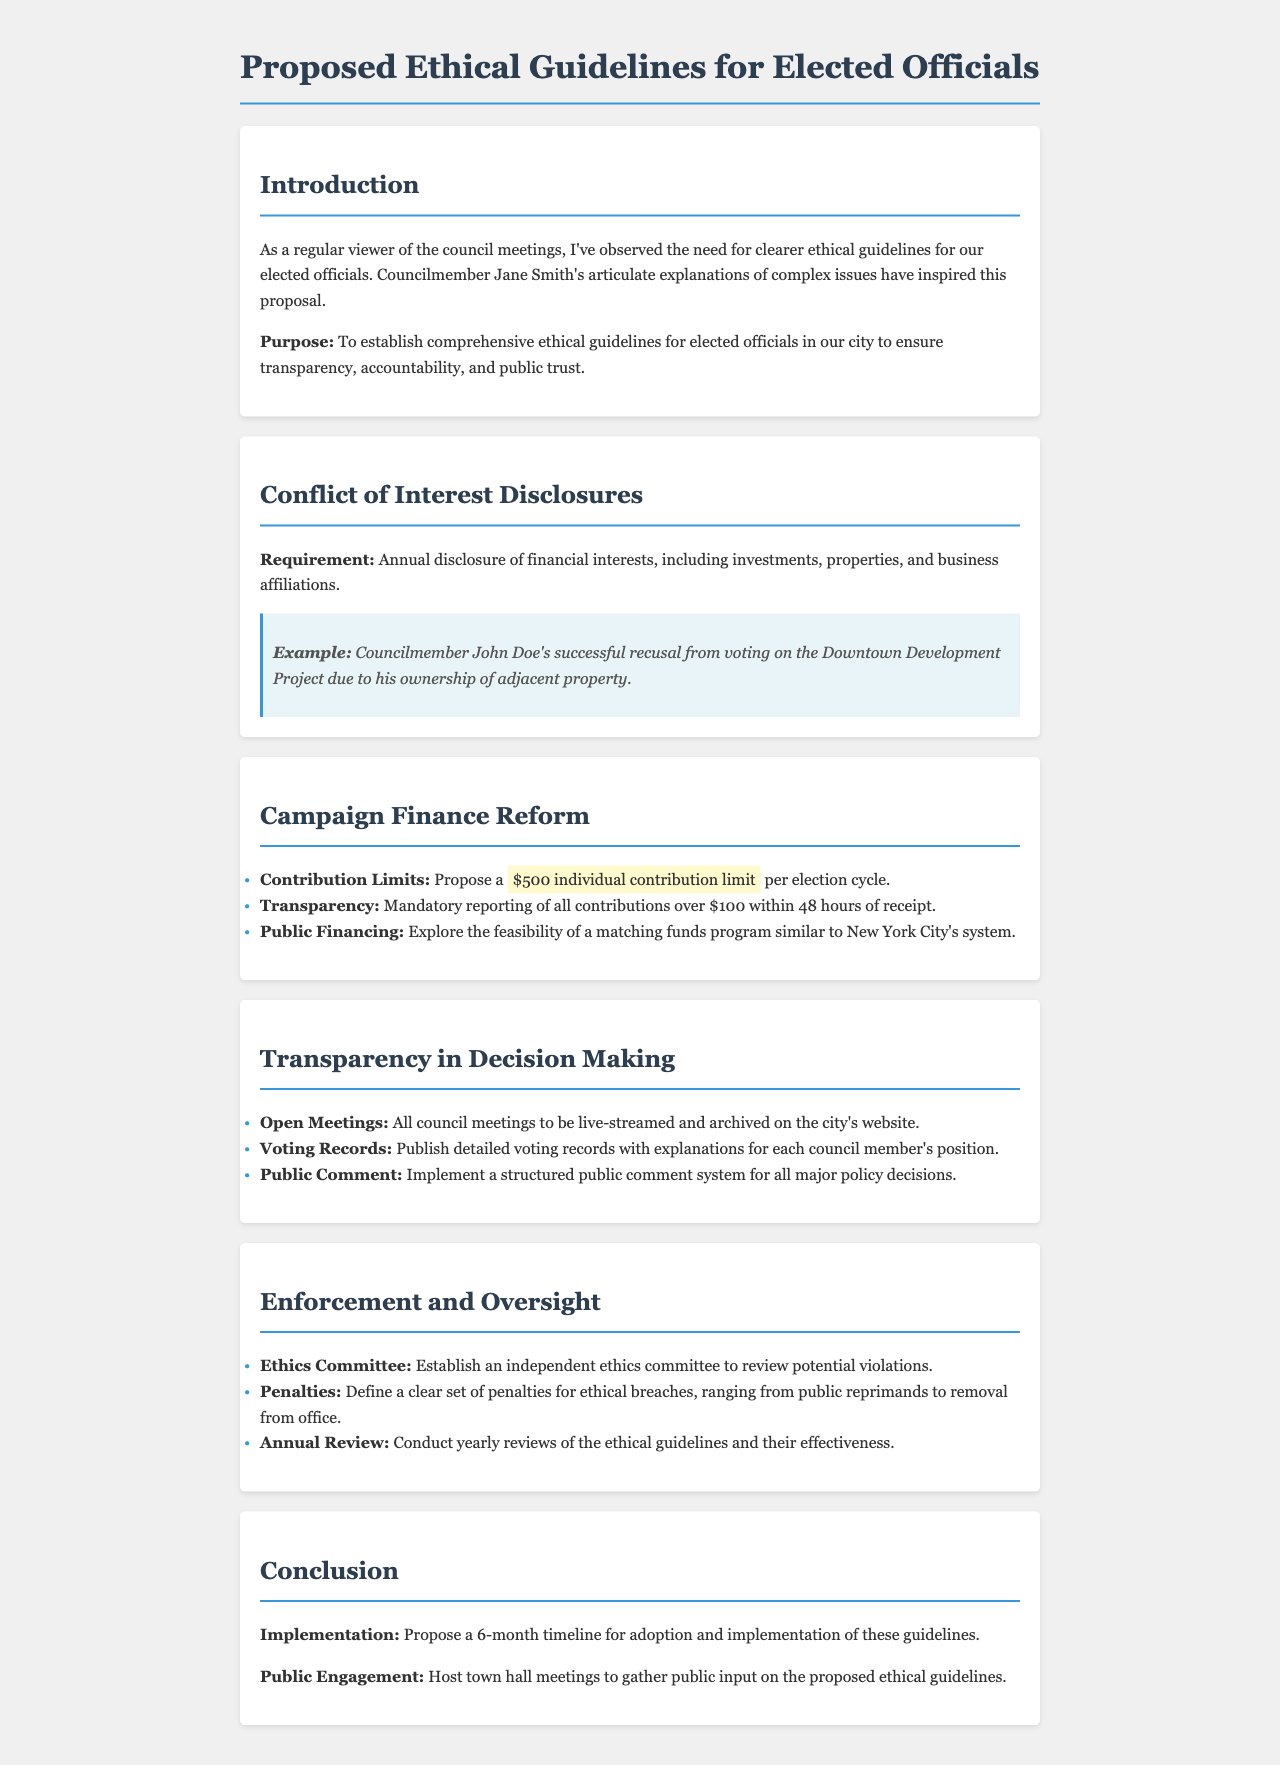what is the purpose of the proposed guidelines? The purpose is to establish comprehensive ethical guidelines for elected officials in our city to ensure transparency, accountability, and public trust.
Answer: to establish comprehensive ethical guidelines what is the annual disclosure requirement for elected officials? The requirement states that there must be an annual disclosure of financial interests, including investments, properties, and business affiliations.
Answer: annual disclosure of financial interests what is the proposed individual contribution limit per election cycle? The proposed contribution limit is stated to be $500 per election cycle.
Answer: $500 how long must contributions over $100 be reported after receipt? Contributions over $100 must be reported within 48 hours of receipt.
Answer: 48 hours what is the recommendation for council meetings? The recommendation is that all council meetings be live-streamed and archived on the city's website.
Answer: live-streamed and archived what should be included in voting records? Voting records should include detailed explanations for each council member's position.
Answer: detailed voting records with explanations what is proposed to gather public input on the guidelines? It is proposed to host town hall meetings to gather public input on the proposed ethical guidelines.
Answer: town hall meetings what is the penalty for ethical breaches mentioned in the document? The document states that penalties can range from public reprimands to removal from office.
Answer: public reprimands to removal from office how often should the ethical guidelines be reviewed? The document mentions that an annual review of the ethical guidelines and their effectiveness should be conducted.
Answer: yearly reviews 